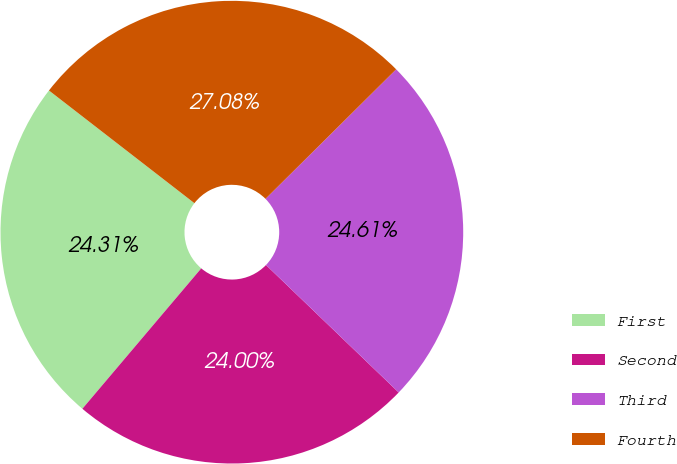Convert chart. <chart><loc_0><loc_0><loc_500><loc_500><pie_chart><fcel>First<fcel>Second<fcel>Third<fcel>Fourth<nl><fcel>24.31%<fcel>24.0%<fcel>24.61%<fcel>27.08%<nl></chart> 